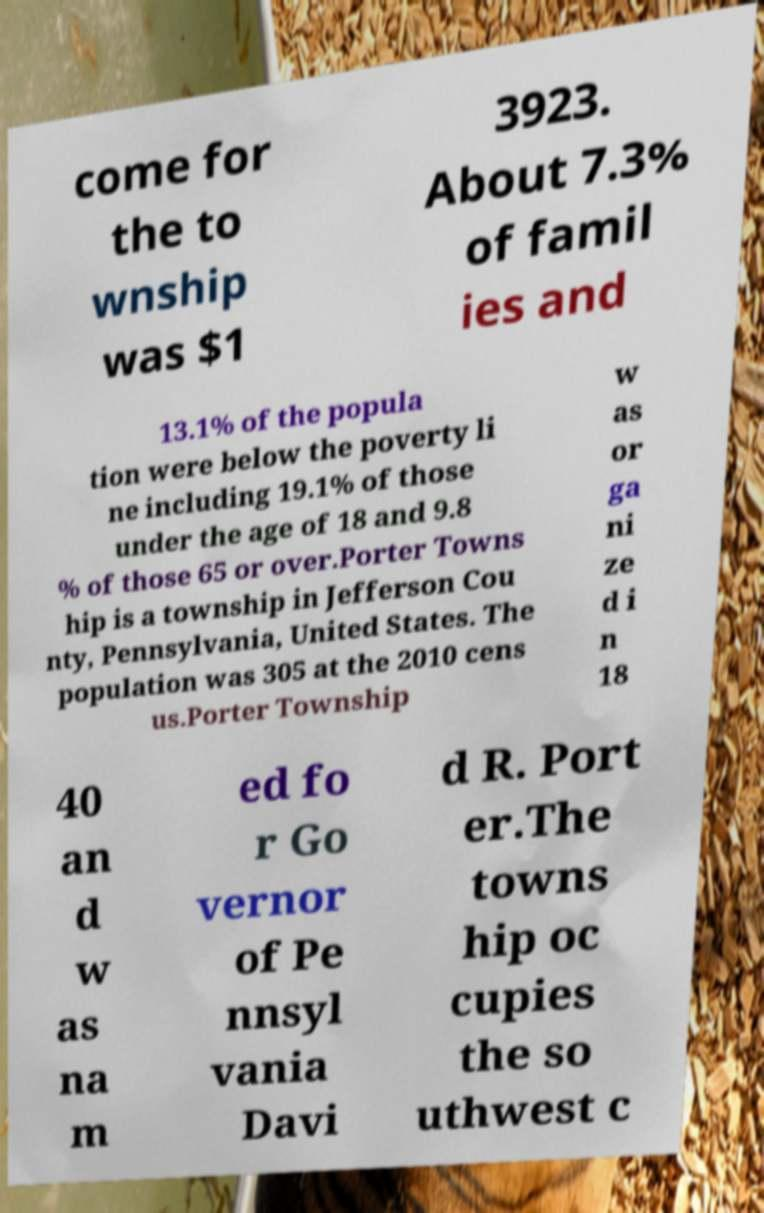For documentation purposes, I need the text within this image transcribed. Could you provide that? come for the to wnship was $1 3923. About 7.3% of famil ies and 13.1% of the popula tion were below the poverty li ne including 19.1% of those under the age of 18 and 9.8 % of those 65 or over.Porter Towns hip is a township in Jefferson Cou nty, Pennsylvania, United States. The population was 305 at the 2010 cens us.Porter Township w as or ga ni ze d i n 18 40 an d w as na m ed fo r Go vernor of Pe nnsyl vania Davi d R. Port er.The towns hip oc cupies the so uthwest c 